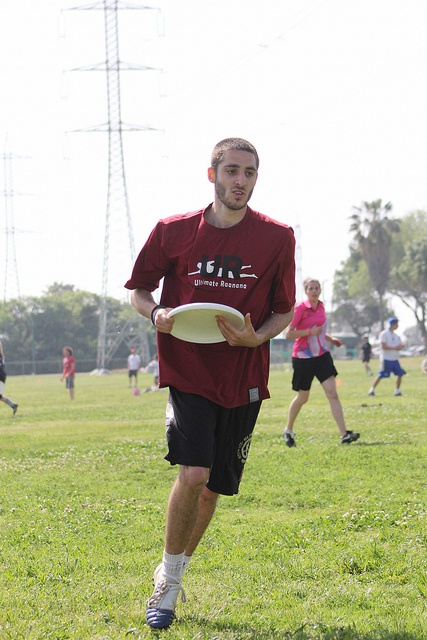Describe the objects in this image and their specific colors. I can see people in white, maroon, black, and gray tones, people in white, black, gray, brown, and tan tones, frisbee in white, olive, darkgray, gray, and lightgray tones, people in white, darkgray, lightgray, and gray tones, and people in white, brown, darkgray, gray, and lightpink tones in this image. 